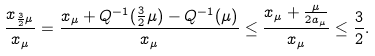Convert formula to latex. <formula><loc_0><loc_0><loc_500><loc_500>\frac { x _ { \frac { 3 } { 2 } \mu } } { x _ { \mu } } = \frac { x _ { \mu } + Q ^ { - 1 } ( \frac { 3 } { 2 } \mu ) - Q ^ { - 1 } ( \mu ) } { x _ { \mu } } \leq \frac { x _ { \mu } + \frac { \mu } { 2 a _ { \mu } } } { x _ { \mu } } \leq \frac { 3 } { 2 } .</formula> 